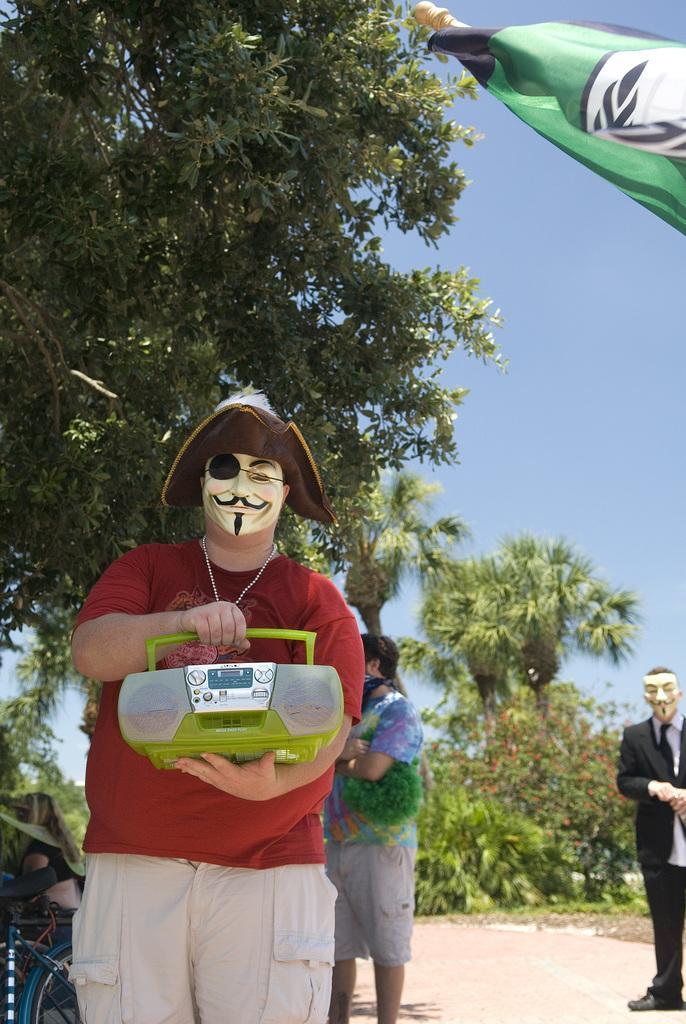Please provide a concise description of this image. In this picture we can observe a man, wearing a face mask and a hat on his head. He is wearing a red color T shirt and holding a green color radio in his hands. There are some people standing. We can observe trees in this picture. In the background there is a sky. 